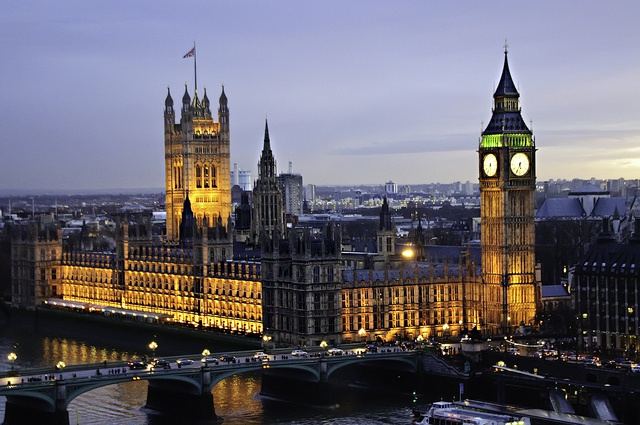Describe the objects in this image and their specific colors. I can see boat in darkgray, black, gray, and navy tones, boat in darkgray, black, gray, and navy tones, clock in darkgray, ivory, black, and khaki tones, clock in darkgray, ivory, khaki, and olive tones, and car in darkgray, black, navy, gray, and maroon tones in this image. 